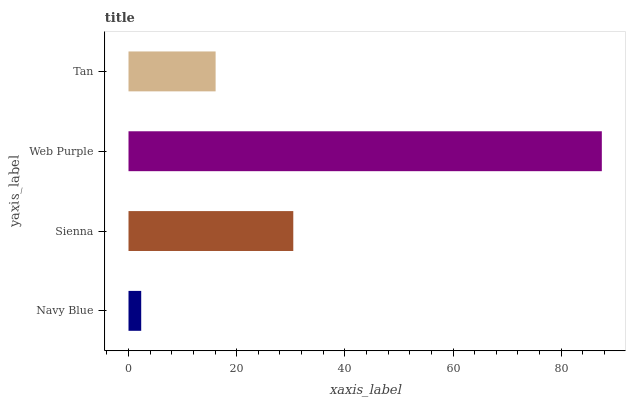Is Navy Blue the minimum?
Answer yes or no. Yes. Is Web Purple the maximum?
Answer yes or no. Yes. Is Sienna the minimum?
Answer yes or no. No. Is Sienna the maximum?
Answer yes or no. No. Is Sienna greater than Navy Blue?
Answer yes or no. Yes. Is Navy Blue less than Sienna?
Answer yes or no. Yes. Is Navy Blue greater than Sienna?
Answer yes or no. No. Is Sienna less than Navy Blue?
Answer yes or no. No. Is Sienna the high median?
Answer yes or no. Yes. Is Tan the low median?
Answer yes or no. Yes. Is Tan the high median?
Answer yes or no. No. Is Navy Blue the low median?
Answer yes or no. No. 